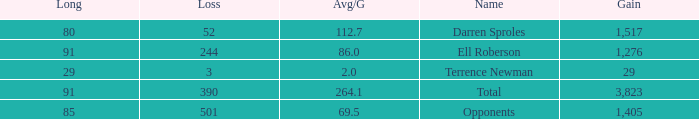When the Gain is 29, and the average per game is 2, and the player lost less than 390 yards, what's the sum of the Long yards? None. 